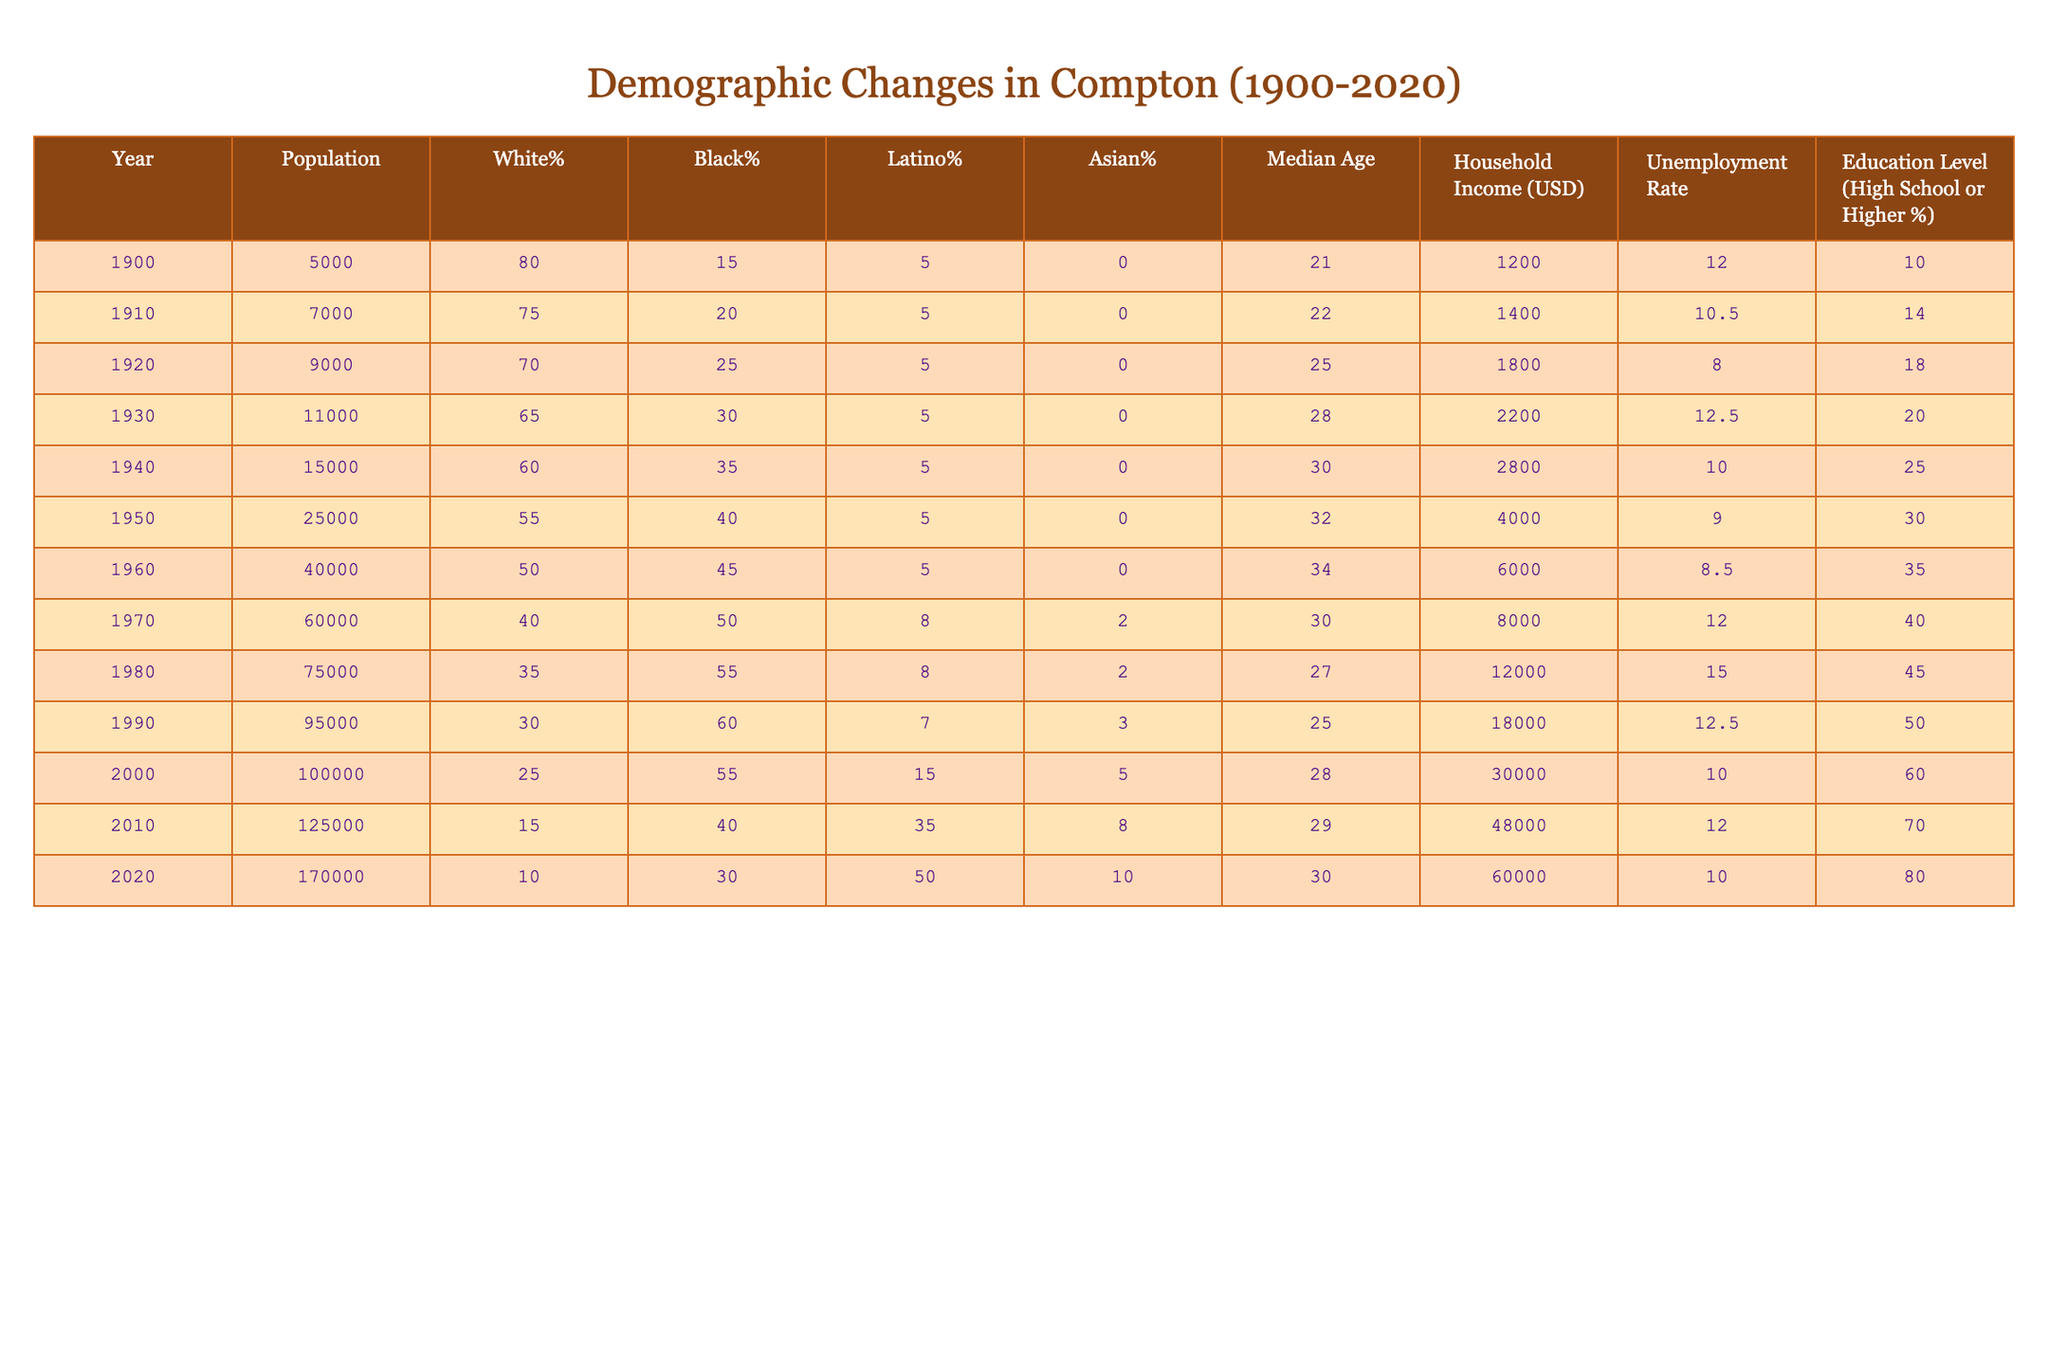What was the population of Compton in 1950? The population listed for the year 1950 in the table is 25,000.
Answer: 25,000 How much did the median age change from 1900 to 2020? The median age in 1900 was 21, and in 2020 it was 30. Therefore, the change is 30 - 21 = 9 years.
Answer: 9 years What percentage of the population was Latino in 1970? The table shows that the Latino percentage in 1970 was 8%.
Answer: 8% In which year did the unemployment rate drop below 10% for the first time? The unemployment rate was 10% in 1940 and dropped to 9% in 1950 and continued to decrease afterward. Thus, it first dropped below 10% in 1950.
Answer: 1950 What is the average household income from 2000 to 2020? The household incomes are 30,000 (2000), 48,000 (2010), and 60,000 (2020). The average is (30,000 + 48,000 + 60,000) / 3 = 46,000.
Answer: 46,000 Is the Black population percentage higher in 1990 or 1960? The Black population percentage in 1990 was 60%, while in 1960 it was 45%. So, 60% is higher than 45%.
Answer: Yes By how much did the White percentage decrease from 1900 to 2020? The White percentage in 1900 was 80%, and in 2020 it was 10%. The decrease is 80 - 10 = 70%.
Answer: 70% What was the highest recorded unemployment rate and in which year did it occur? The highest unemployment rate recorded in the table was 15% in 1980.
Answer: 15%, 1980 If the demographic changes keep following the trend observed from 2000 to 2020, what might we expect the Latino percentage to be in 2030? The Latino percentage increased from 15% in 2000 to 50% in 2020, a total change of 35%. If we assume a similar change over the next decade, it could increase by around 17.5%, leading to an estimated 67.5% in 2030.
Answer: Approximately 67.5% What was the percentage of the population with a high school education or higher in 1980? The table states that the education level in 1980 was 45%.
Answer: 45% 